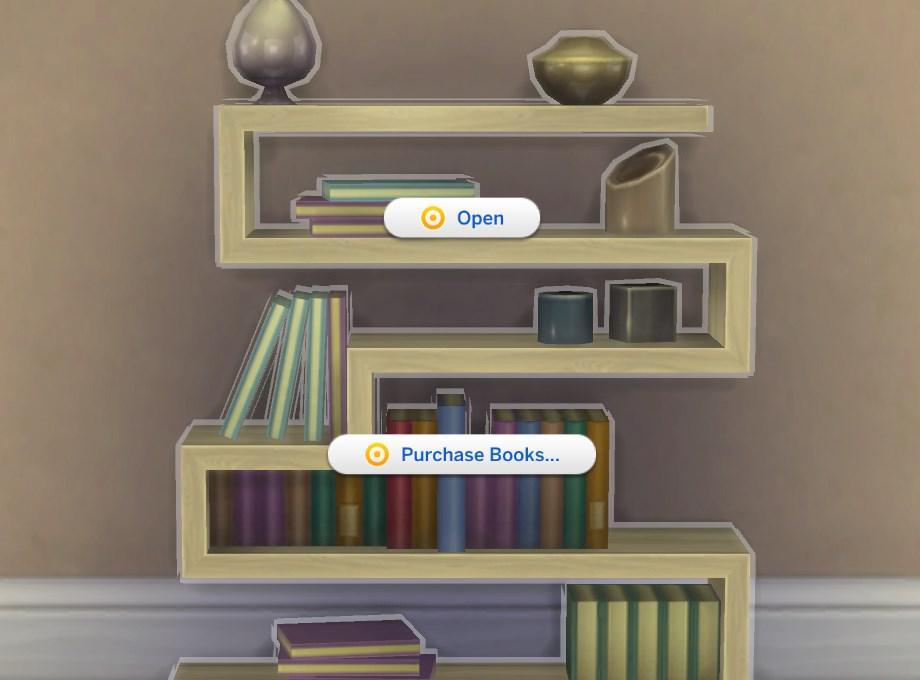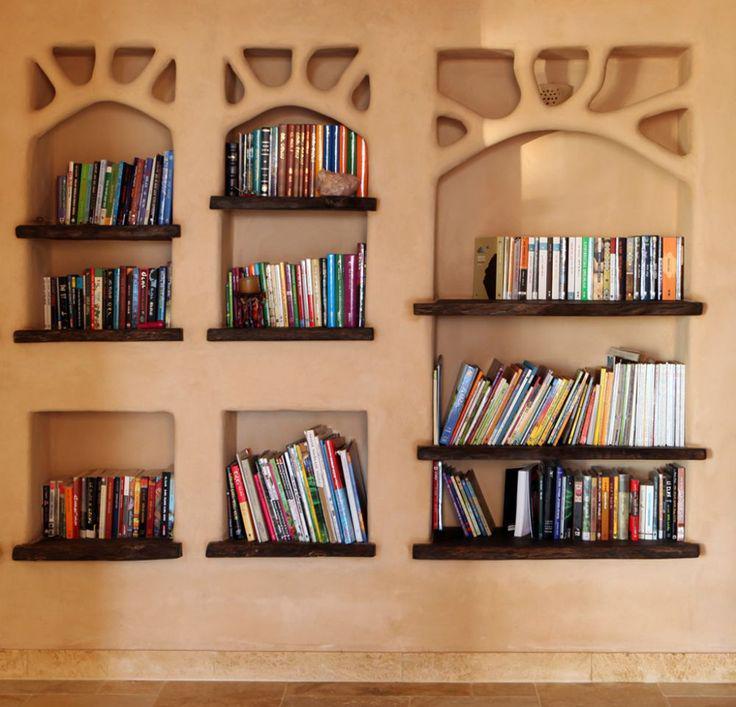The first image is the image on the left, the second image is the image on the right. For the images shown, is this caption "The bookshelves in at least one image angle around the corner of room, so that they  extend outward on two walls." true? Answer yes or no. No. The first image is the image on the left, the second image is the image on the right. Assess this claim about the two images: "Bookshelves are attached to the wall in a room;". Correct or not? Answer yes or no. Yes. 